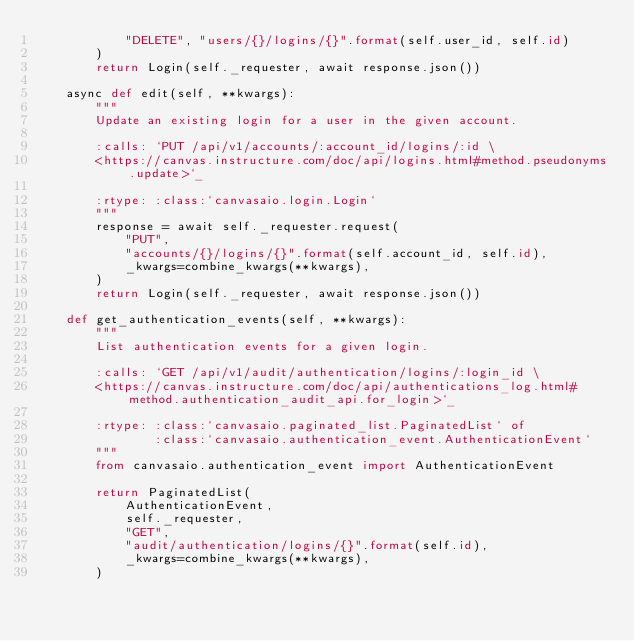<code> <loc_0><loc_0><loc_500><loc_500><_Python_>            "DELETE", "users/{}/logins/{}".format(self.user_id, self.id)
        )
        return Login(self._requester, await response.json())

    async def edit(self, **kwargs):
        """
        Update an existing login for a user in the given account.

        :calls: `PUT /api/v1/accounts/:account_id/logins/:id \
        <https://canvas.instructure.com/doc/api/logins.html#method.pseudonyms.update>`_

        :rtype: :class:`canvasaio.login.Login`
        """
        response = await self._requester.request(
            "PUT",
            "accounts/{}/logins/{}".format(self.account_id, self.id),
            _kwargs=combine_kwargs(**kwargs),
        )
        return Login(self._requester, await response.json())

    def get_authentication_events(self, **kwargs):
        """
        List authentication events for a given login.

        :calls: `GET /api/v1/audit/authentication/logins/:login_id \
        <https://canvas.instructure.com/doc/api/authentications_log.html#method.authentication_audit_api.for_login>`_

        :rtype: :class:`canvasaio.paginated_list.PaginatedList` of
                :class:`canvasaio.authentication_event.AuthenticationEvent`
        """
        from canvasaio.authentication_event import AuthenticationEvent

        return PaginatedList(
            AuthenticationEvent,
            self._requester,
            "GET",
            "audit/authentication/logins/{}".format(self.id),
            _kwargs=combine_kwargs(**kwargs),
        )
</code> 